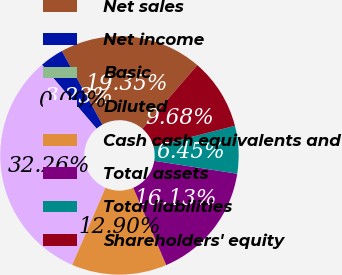<chart> <loc_0><loc_0><loc_500><loc_500><pie_chart><fcel>Net sales<fcel>Net income<fcel>Basic<fcel>Diluted<fcel>Cash cash equivalents and<fcel>Total assets<fcel>Total liabilities<fcel>Shareholders' equity<nl><fcel>19.35%<fcel>3.23%<fcel>0.0%<fcel>32.26%<fcel>12.9%<fcel>16.13%<fcel>6.45%<fcel>9.68%<nl></chart> 